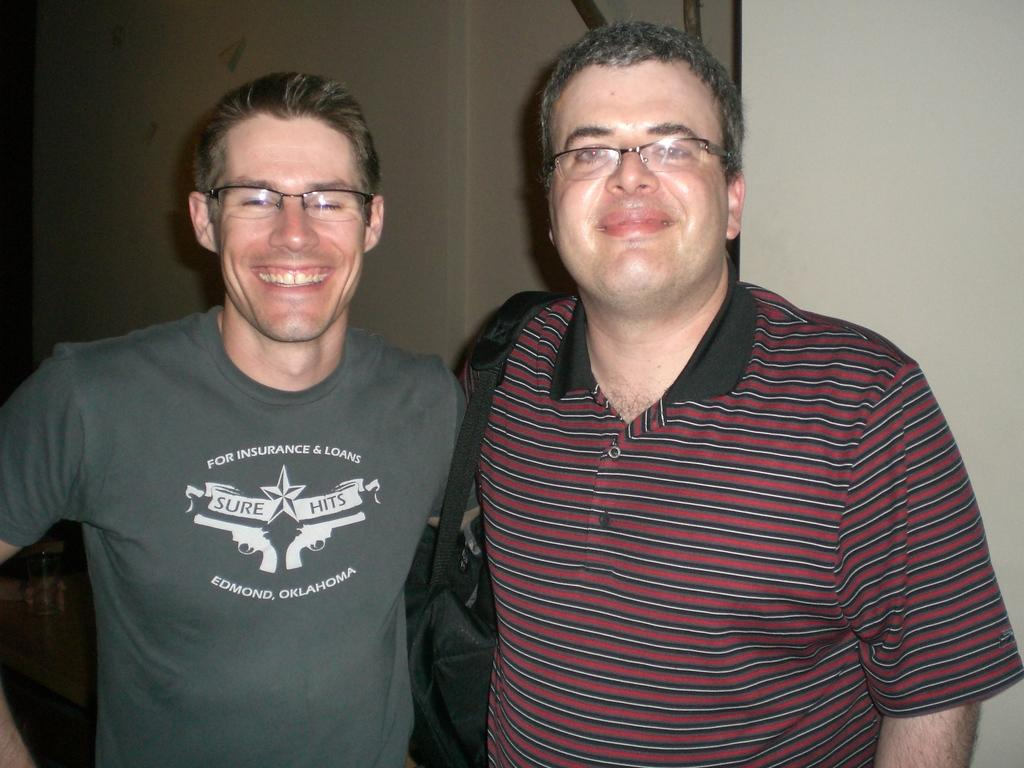How many individuals are present in the image? There are two people in the image. What are the people doing in the image? Both people are standing. What is the emotional expression of the people in the image? The people are smiling. What is the distance between the two people in the image? The provided facts do not mention the distance between the two people, so it cannot be determined from the image. 